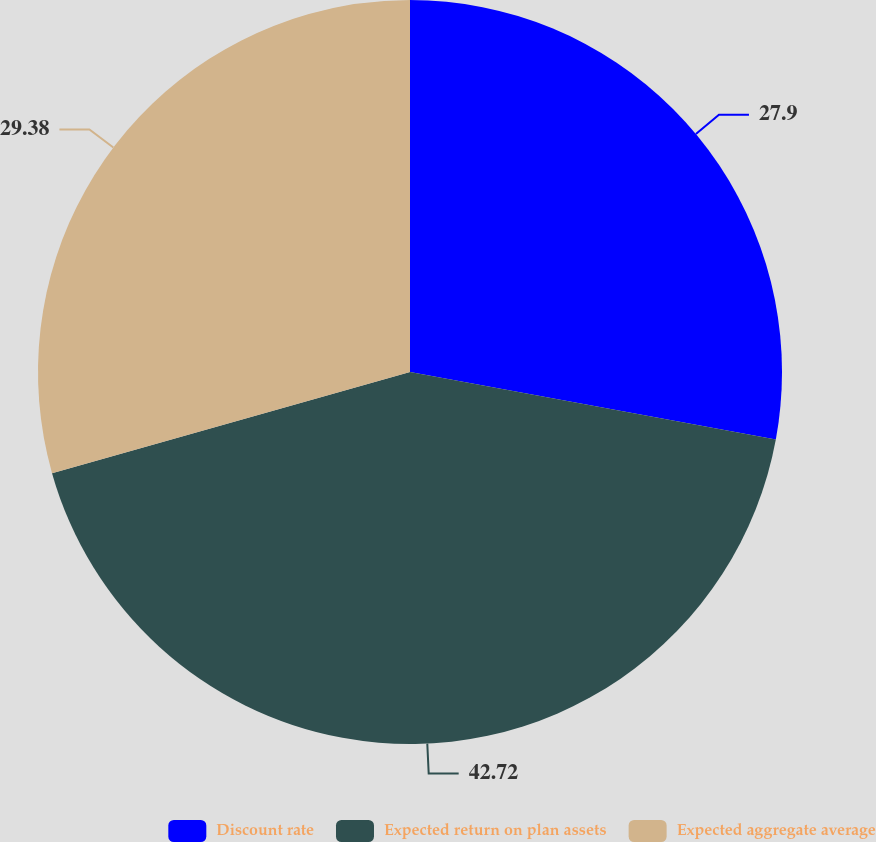Convert chart. <chart><loc_0><loc_0><loc_500><loc_500><pie_chart><fcel>Discount rate<fcel>Expected return on plan assets<fcel>Expected aggregate average<nl><fcel>27.9%<fcel>42.71%<fcel>29.38%<nl></chart> 